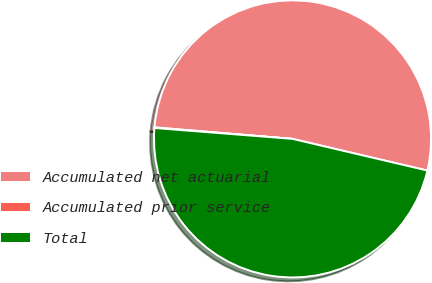Convert chart to OTSL. <chart><loc_0><loc_0><loc_500><loc_500><pie_chart><fcel>Accumulated net actuarial<fcel>Accumulated prior service<fcel>Total<nl><fcel>52.35%<fcel>0.07%<fcel>47.59%<nl></chart> 